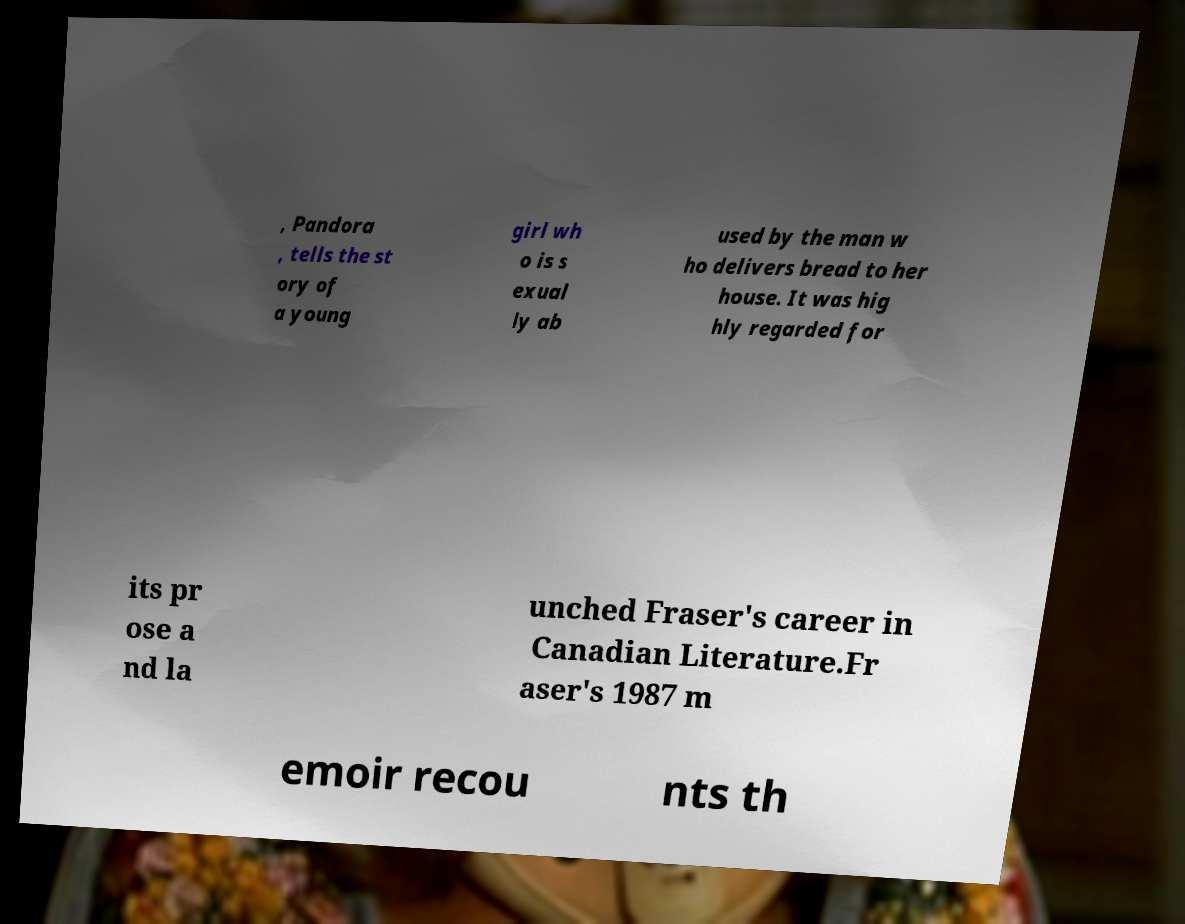What messages or text are displayed in this image? I need them in a readable, typed format. , Pandora , tells the st ory of a young girl wh o is s exual ly ab used by the man w ho delivers bread to her house. It was hig hly regarded for its pr ose a nd la unched Fraser's career in Canadian Literature.Fr aser's 1987 m emoir recou nts th 